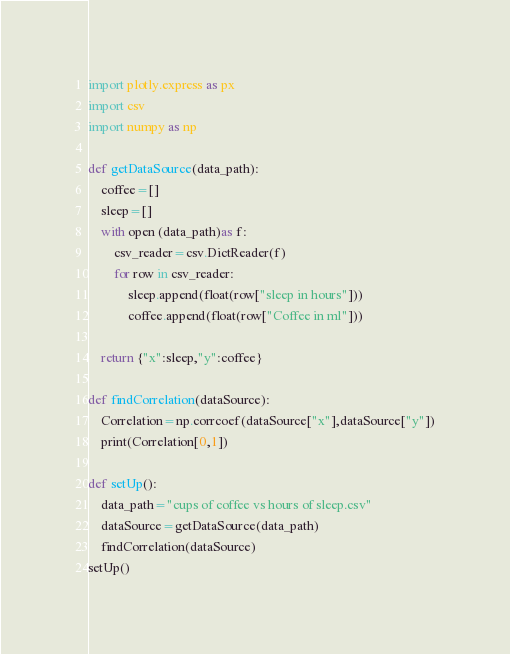<code> <loc_0><loc_0><loc_500><loc_500><_Python_>import plotly.express as px
import csv
import numpy as np

def getDataSource(data_path):
    coffee=[]
    sleep=[]
    with open (data_path)as f:
        csv_reader=csv.DictReader(f)
        for row in csv_reader:
            sleep.append(float(row["sleep in hours"]))
            coffee.append(float(row["Coffee in ml"]))

    return {"x":sleep,"y":coffee}

def findCorrelation(dataSource):
    Correlation=np.corrcoef(dataSource["x"],dataSource["y"])
    print(Correlation[0,1])

def setUp():
    data_path="cups of coffee vs hours of sleep.csv"
    dataSource=getDataSource(data_path)
    findCorrelation(dataSource)
setUp()
</code> 